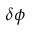Convert formula to latex. <formula><loc_0><loc_0><loc_500><loc_500>\delta \phi</formula> 